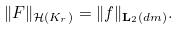Convert formula to latex. <formula><loc_0><loc_0><loc_500><loc_500>\| F \| _ { { \mathcal { H } } ( K _ { r } ) } = \| f \| _ { { \mathbf L } _ { 2 } ( d m ) } .</formula> 